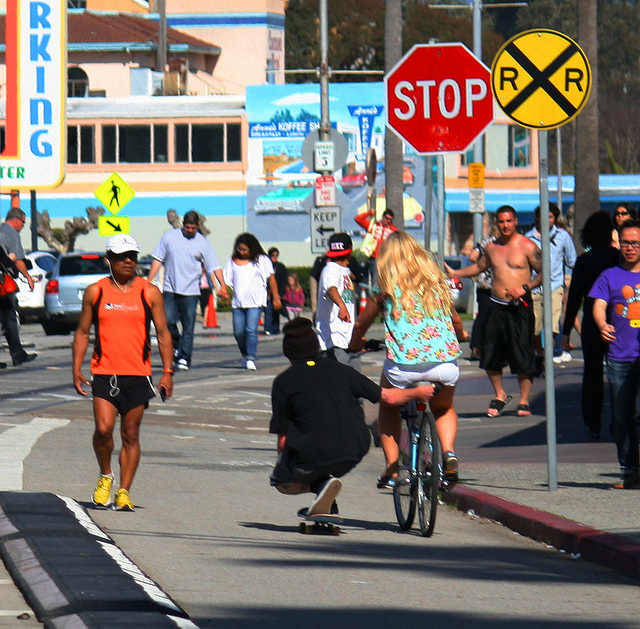Extract all visible text content from this image. R STOP R RKInG KEEO TER 